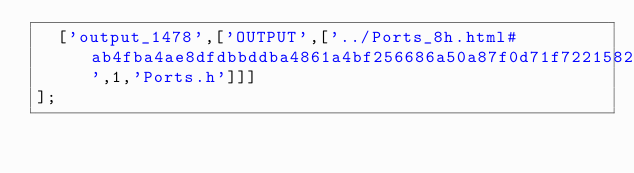Convert code to text. <code><loc_0><loc_0><loc_500><loc_500><_JavaScript_>  ['output_1478',['OUTPUT',['../Ports_8h.html#ab4fba4ae8dfdbbddba4861a4bf256686a50a87f0d71f7221582dad4bf507a0f34',1,'Ports.h']]]
];
</code> 